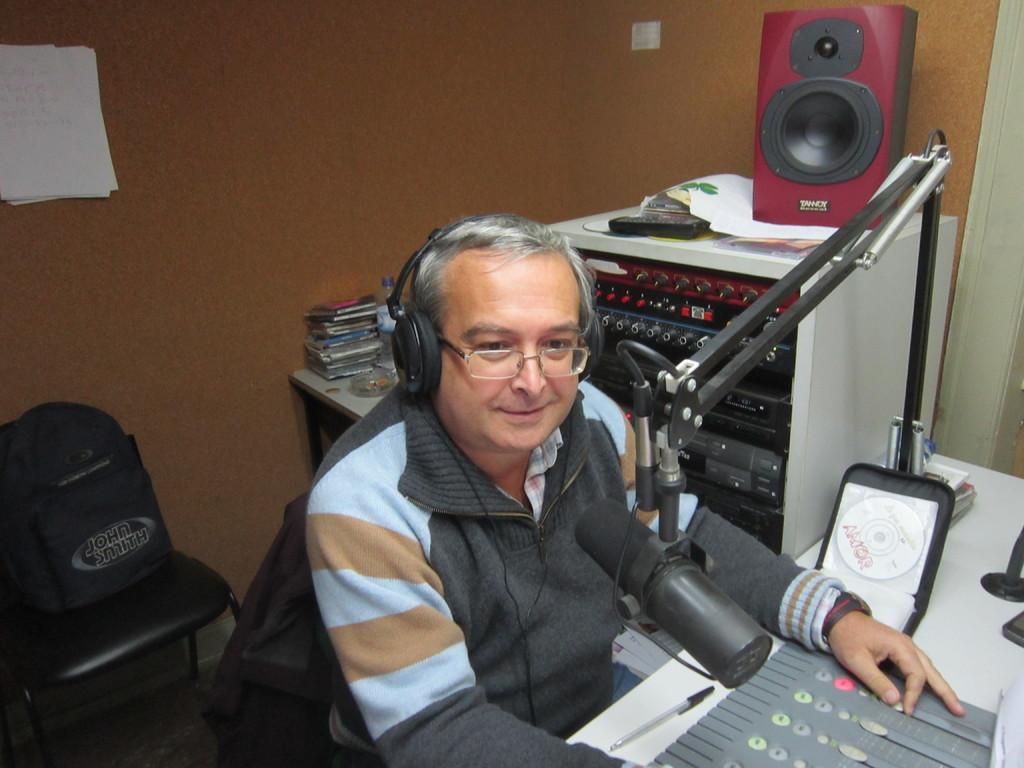Describe this image in one or two sentences. In the image we can see a man sitting, these are the headsets, sound box. This is a microphone and chair. 